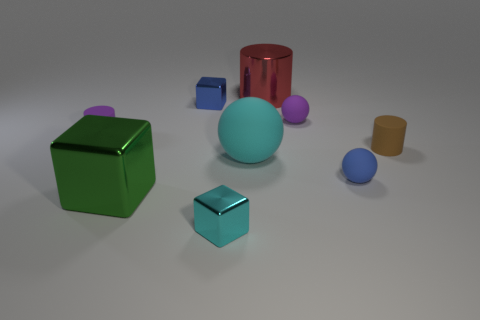Subtract all tiny cylinders. How many cylinders are left? 1 Add 1 green cubes. How many objects exist? 10 Subtract all purple spheres. How many spheres are left? 2 Subtract all blue metallic objects. Subtract all small purple objects. How many objects are left? 6 Add 5 tiny brown cylinders. How many tiny brown cylinders are left? 6 Add 5 red matte cylinders. How many red matte cylinders exist? 5 Subtract 0 red cubes. How many objects are left? 9 Subtract all cylinders. How many objects are left? 6 Subtract 2 balls. How many balls are left? 1 Subtract all blue cylinders. Subtract all purple cubes. How many cylinders are left? 3 